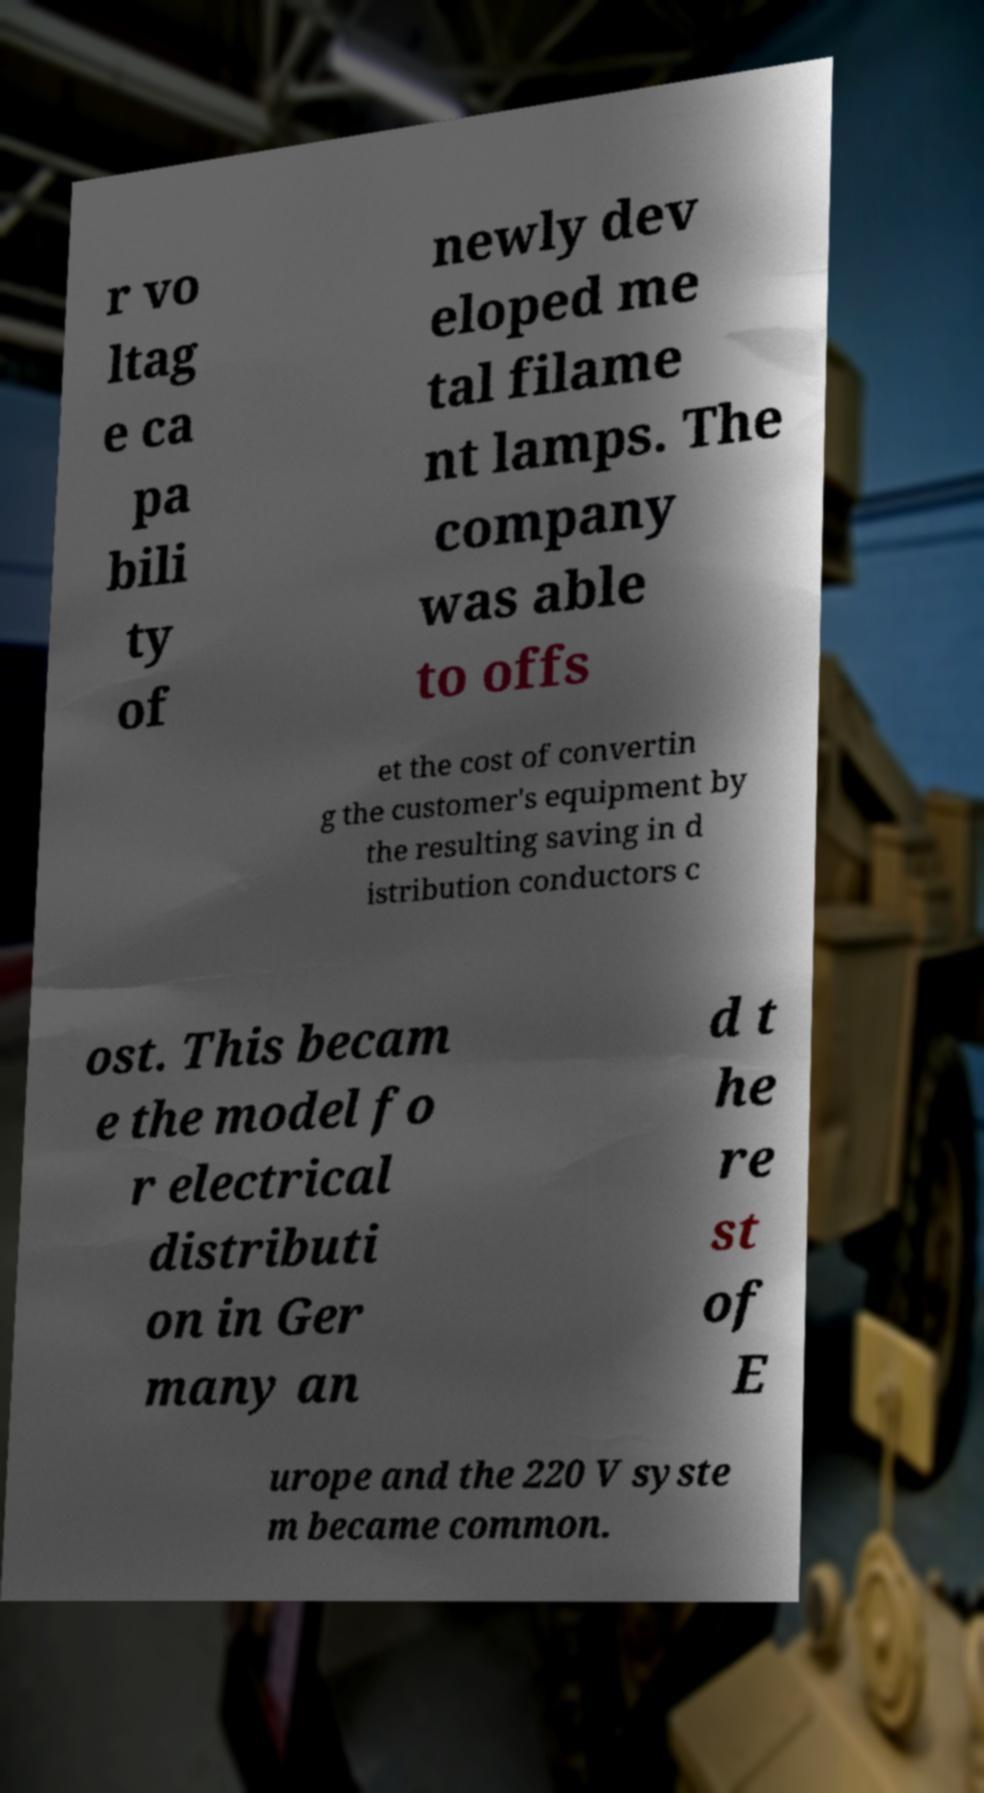Please read and relay the text visible in this image. What does it say? r vo ltag e ca pa bili ty of newly dev eloped me tal filame nt lamps. The company was able to offs et the cost of convertin g the customer's equipment by the resulting saving in d istribution conductors c ost. This becam e the model fo r electrical distributi on in Ger many an d t he re st of E urope and the 220 V syste m became common. 